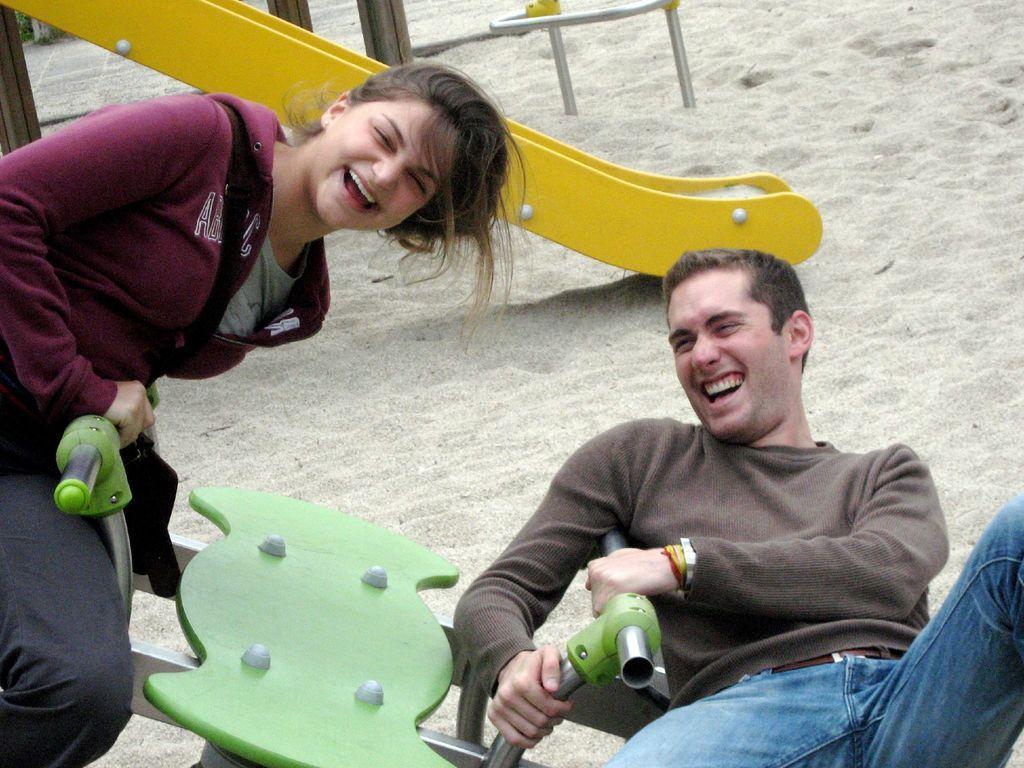How would you summarize this image in a sentence or two? In the center of the image we can see two persons are sitting on a seesaw. And we can see they are in different costumes and they are smiling. In the background there is a slide, rods, sand and poles. 